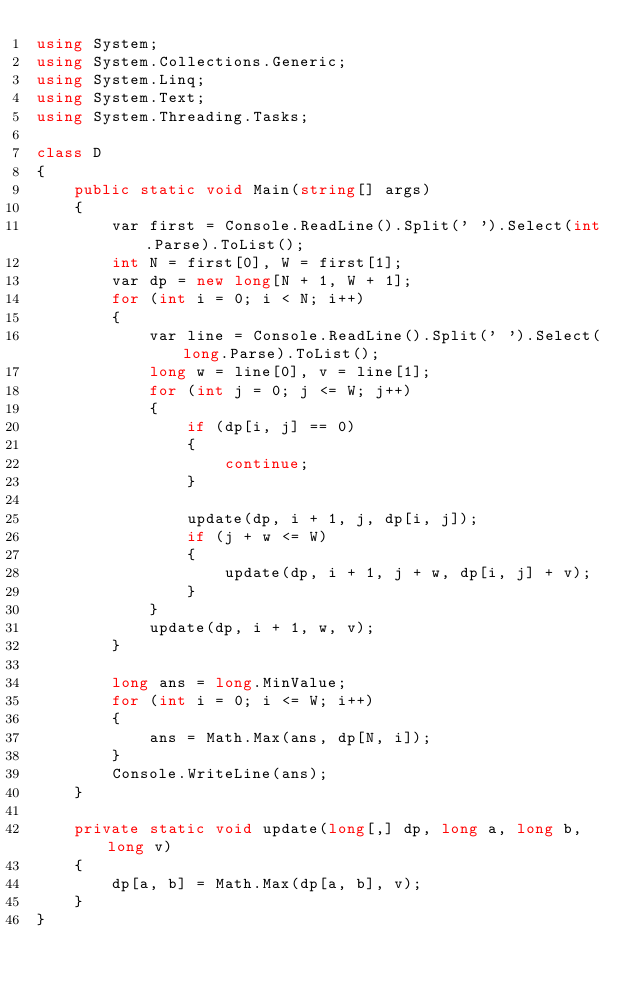<code> <loc_0><loc_0><loc_500><loc_500><_C#_>using System;
using System.Collections.Generic;
using System.Linq;
using System.Text;
using System.Threading.Tasks;

class D
{
    public static void Main(string[] args)
    {
        var first = Console.ReadLine().Split(' ').Select(int.Parse).ToList();
        int N = first[0], W = first[1];
        var dp = new long[N + 1, W + 1];
        for (int i = 0; i < N; i++)
        {
            var line = Console.ReadLine().Split(' ').Select(long.Parse).ToList();
            long w = line[0], v = line[1];
            for (int j = 0; j <= W; j++)
            {
                if (dp[i, j] == 0)
                {
                    continue;
                }

                update(dp, i + 1, j, dp[i, j]);
                if (j + w <= W)
                {
                    update(dp, i + 1, j + w, dp[i, j] + v);
                }
            }
            update(dp, i + 1, w, v);
        }

        long ans = long.MinValue;
        for (int i = 0; i <= W; i++)
        {
            ans = Math.Max(ans, dp[N, i]);
        }
        Console.WriteLine(ans);
    }

    private static void update(long[,] dp, long a, long b, long v)
    {
        dp[a, b] = Math.Max(dp[a, b], v);
    }
}</code> 